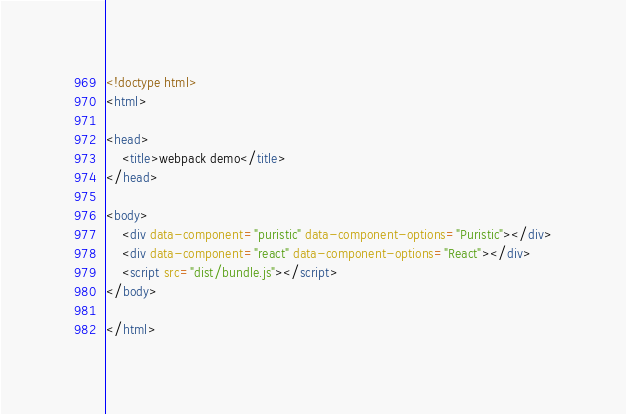Convert code to text. <code><loc_0><loc_0><loc_500><loc_500><_HTML_><!doctype html>
<html>

<head>
    <title>webpack demo</title>
</head>

<body>
    <div data-component="puristic" data-component-options="Puristic"></div>
    <div data-component="react" data-component-options="React"></div>
    <script src="dist/bundle.js"></script>
</body>

</html></code> 